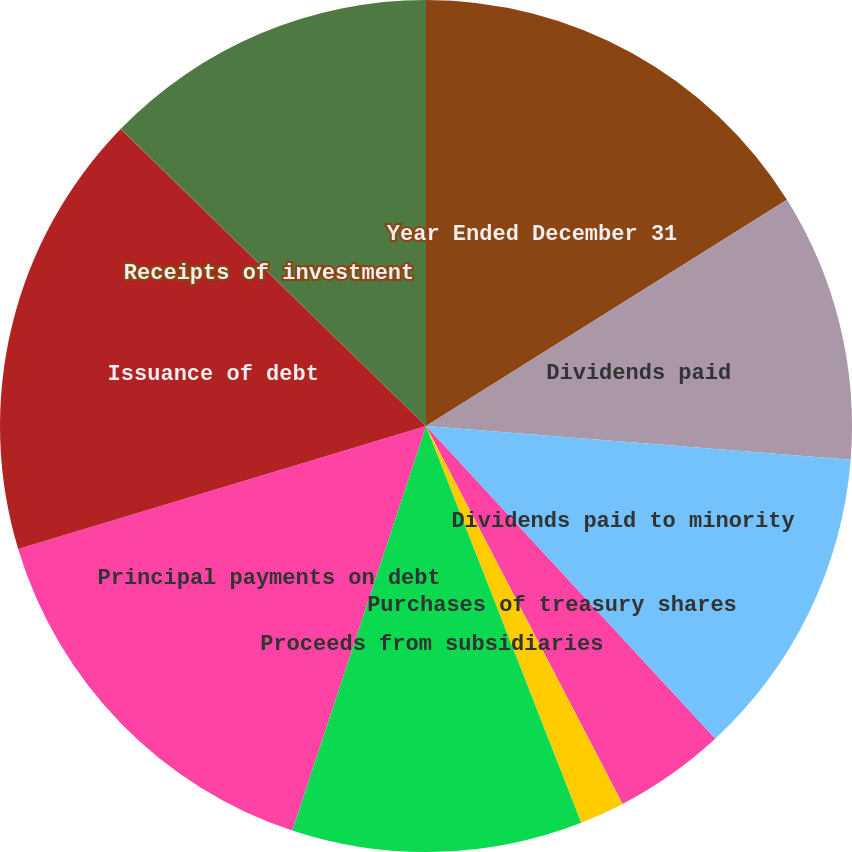Convert chart. <chart><loc_0><loc_0><loc_500><loc_500><pie_chart><fcel>Year Ended December 31<fcel>Dividends paid<fcel>Dividends paid to minority<fcel>Purchases of treasury shares<fcel>Issuance of common stock<fcel>Proceeds from subsidiaries<fcel>Principal payments on debt<fcel>Issuance of debt<fcel>Receipts of investment<fcel>Return of investment contract<nl><fcel>16.09%<fcel>10.17%<fcel>11.86%<fcel>4.24%<fcel>1.7%<fcel>11.02%<fcel>15.25%<fcel>16.94%<fcel>0.01%<fcel>12.71%<nl></chart> 